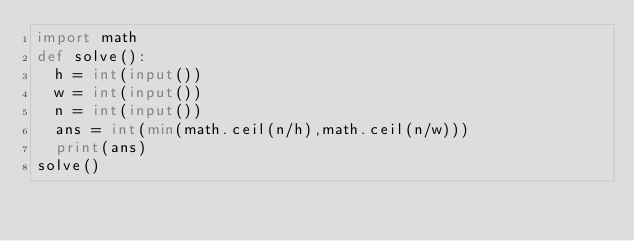<code> <loc_0><loc_0><loc_500><loc_500><_Python_>import math
def solve():
  h = int(input())
  w = int(input())
  n = int(input())
  ans = int(min(math.ceil(n/h),math.ceil(n/w)))
  print(ans)
solve()</code> 